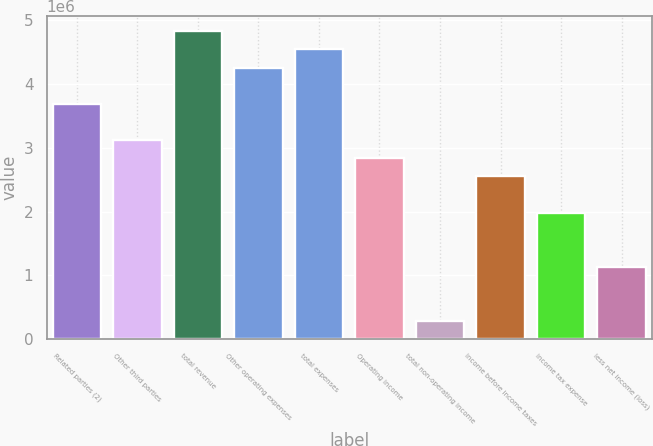Convert chart. <chart><loc_0><loc_0><loc_500><loc_500><bar_chart><fcel>Related parties (2)<fcel>Other third parties<fcel>total revenue<fcel>Other operating expenses<fcel>total expenses<fcel>Operating income<fcel>total non-operating income<fcel>income before income taxes<fcel>income tax expense<fcel>less net income (loss)<nl><fcel>3.68655e+06<fcel>3.11939e+06<fcel>4.82088e+06<fcel>4.25372e+06<fcel>4.5373e+06<fcel>2.83581e+06<fcel>283584<fcel>2.55223e+06<fcel>1.98507e+06<fcel>1.13433e+06<nl></chart> 